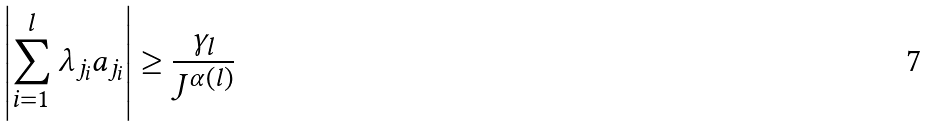Convert formula to latex. <formula><loc_0><loc_0><loc_500><loc_500>\left | \sum _ { i = 1 } ^ { l } \lambda _ { j _ { i } } a _ { j _ { i } } \right | \geq \frac { \gamma _ { l } } { J ^ { \alpha ( l ) } }</formula> 